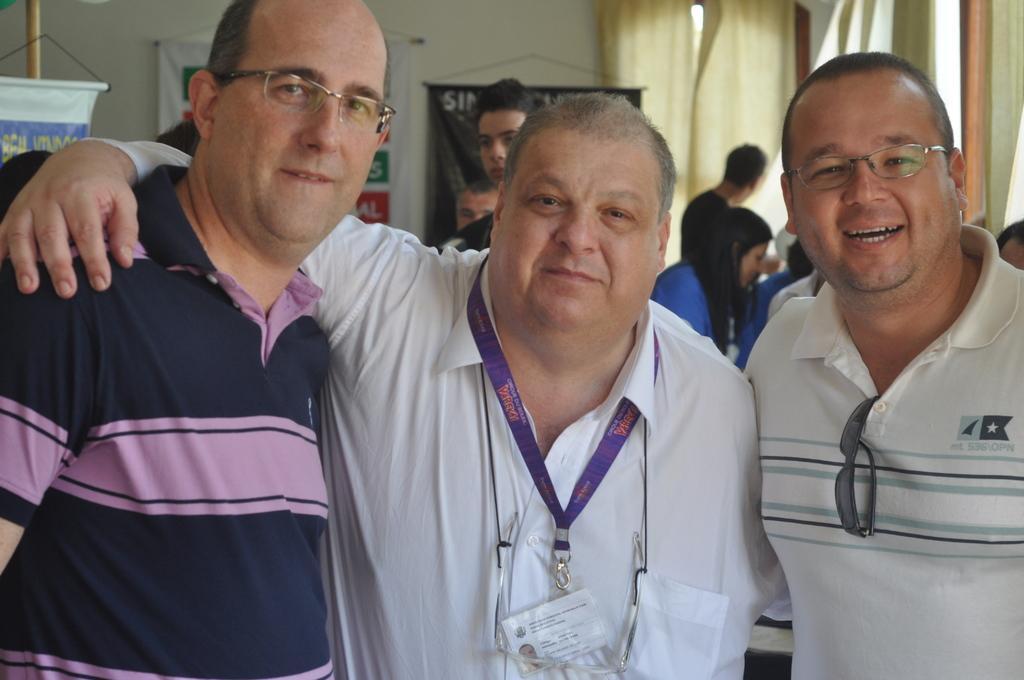In one or two sentences, can you explain what this image depicts? In this image I can see there are three persons visible in the foreground , in the background I can see the wall and persons and window and I can see a curtain hanging on the window. 